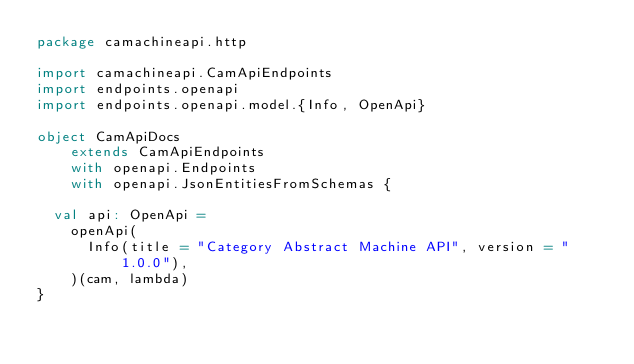Convert code to text. <code><loc_0><loc_0><loc_500><loc_500><_Scala_>package camachineapi.http

import camachineapi.CamApiEndpoints
import endpoints.openapi
import endpoints.openapi.model.{Info, OpenApi}

object CamApiDocs
    extends CamApiEndpoints
    with openapi.Endpoints
    with openapi.JsonEntitiesFromSchemas {

  val api: OpenApi =
    openApi(
      Info(title = "Category Abstract Machine API", version = "1.0.0"),
    )(cam, lambda)
}
</code> 